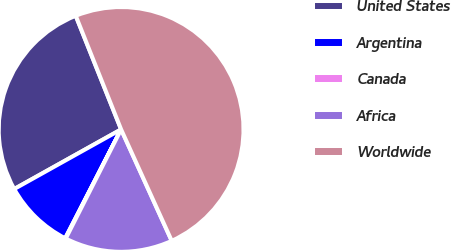Convert chart. <chart><loc_0><loc_0><loc_500><loc_500><pie_chart><fcel>United States<fcel>Argentina<fcel>Canada<fcel>Africa<fcel>Worldwide<nl><fcel>27.05%<fcel>9.35%<fcel>0.08%<fcel>14.26%<fcel>49.26%<nl></chart> 